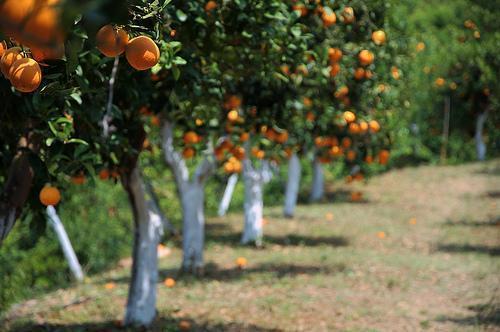How many trees are on the left side?
Give a very brief answer. 5. 